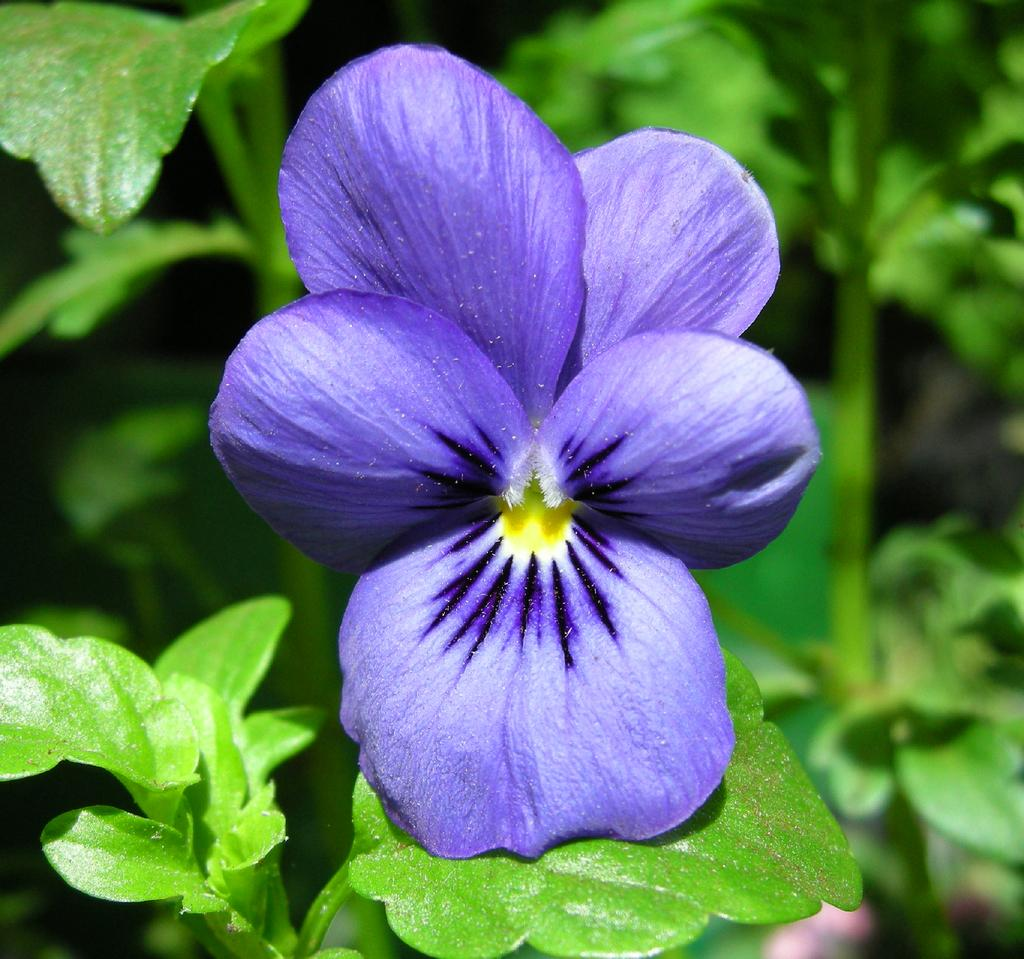What type of living organisms can be seen in the image? There are flowers in the image. Where are the flowers located? The flowers are present on plants. What type of quilt is being used to cover the flowers in the image? There is no quilt present in the image; the flowers are on plants. 